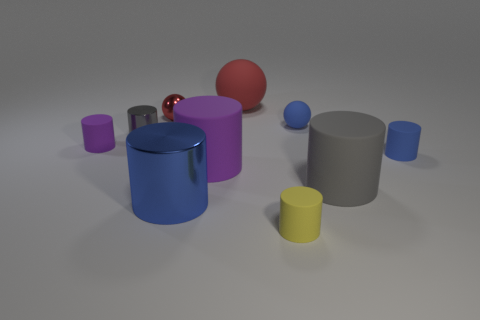Subtract all gray metal cylinders. How many cylinders are left? 6 Subtract all blue balls. How many balls are left? 2 Subtract all spheres. How many objects are left? 7 Subtract all yellow blocks. How many purple cylinders are left? 2 Subtract all large yellow rubber balls. Subtract all big purple matte things. How many objects are left? 9 Add 4 big red spheres. How many big red spheres are left? 5 Add 2 big gray matte blocks. How many big gray matte blocks exist? 2 Subtract 0 red cubes. How many objects are left? 10 Subtract 3 spheres. How many spheres are left? 0 Subtract all green cylinders. Subtract all cyan spheres. How many cylinders are left? 7 